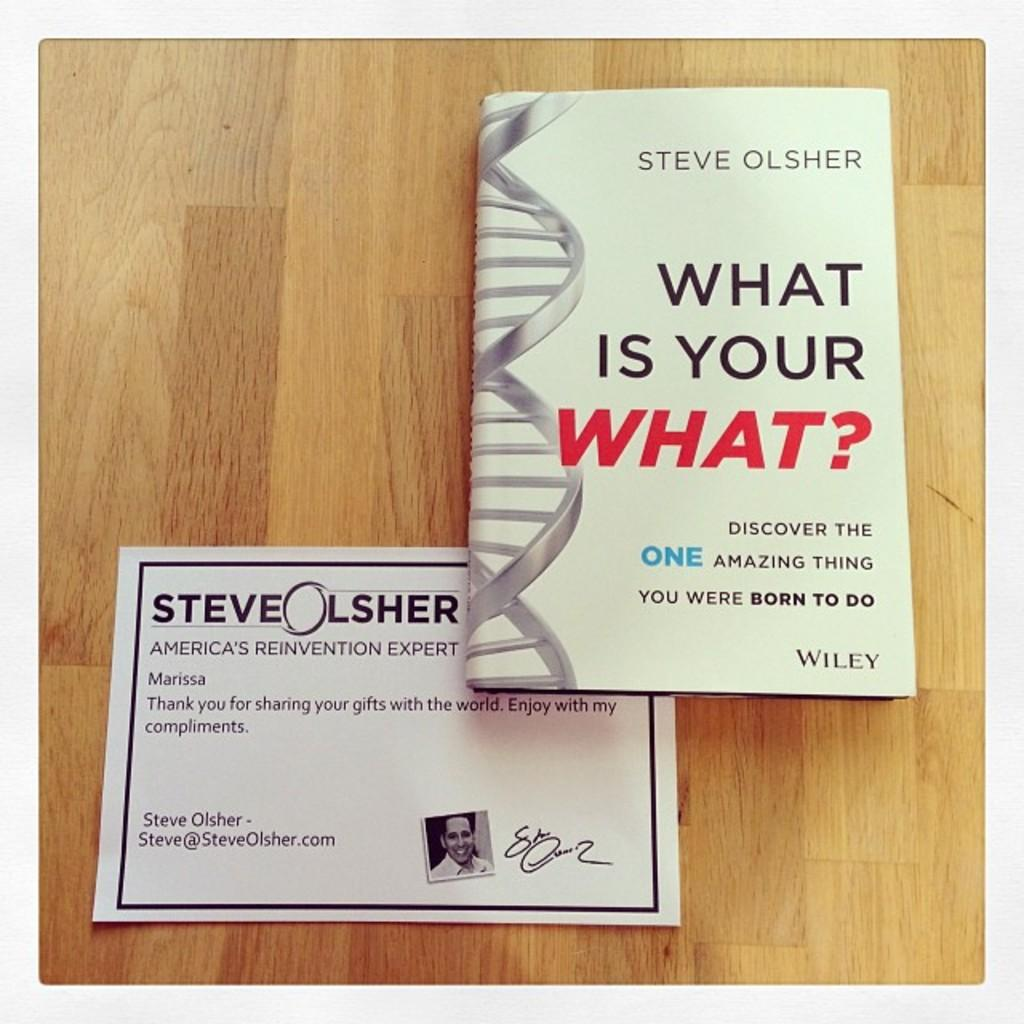<image>
Create a compact narrative representing the image presented. A book by Steve Olsher is on top of a piece of paper with his picture on it. 